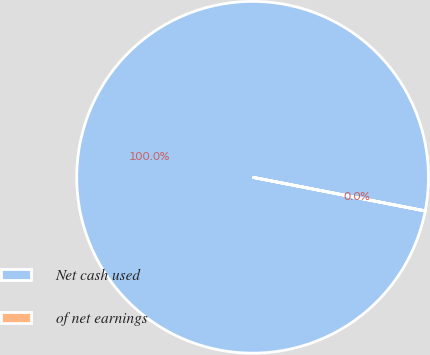<chart> <loc_0><loc_0><loc_500><loc_500><pie_chart><fcel>Net cash used<fcel>of net earnings<nl><fcel>99.98%<fcel>0.02%<nl></chart> 